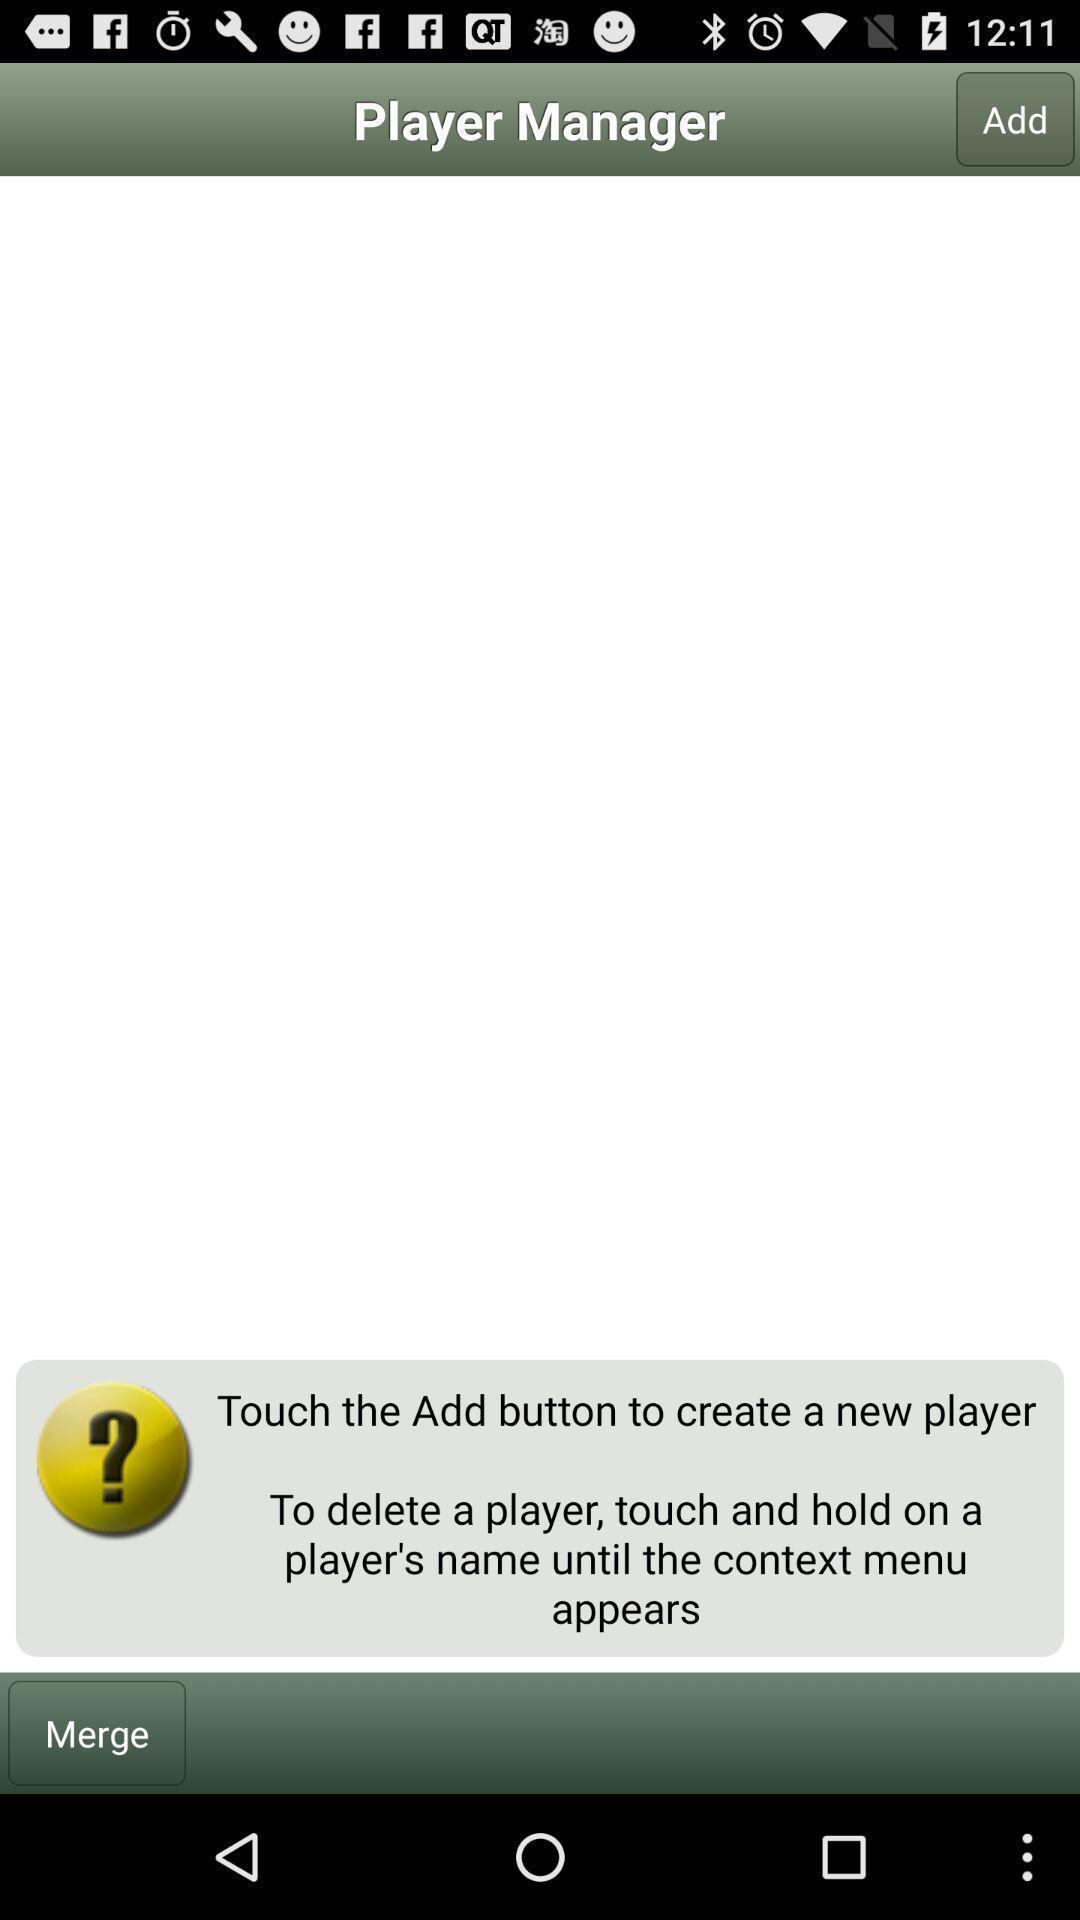Describe the visual elements of this screenshot. Screen shows about a player manager. 